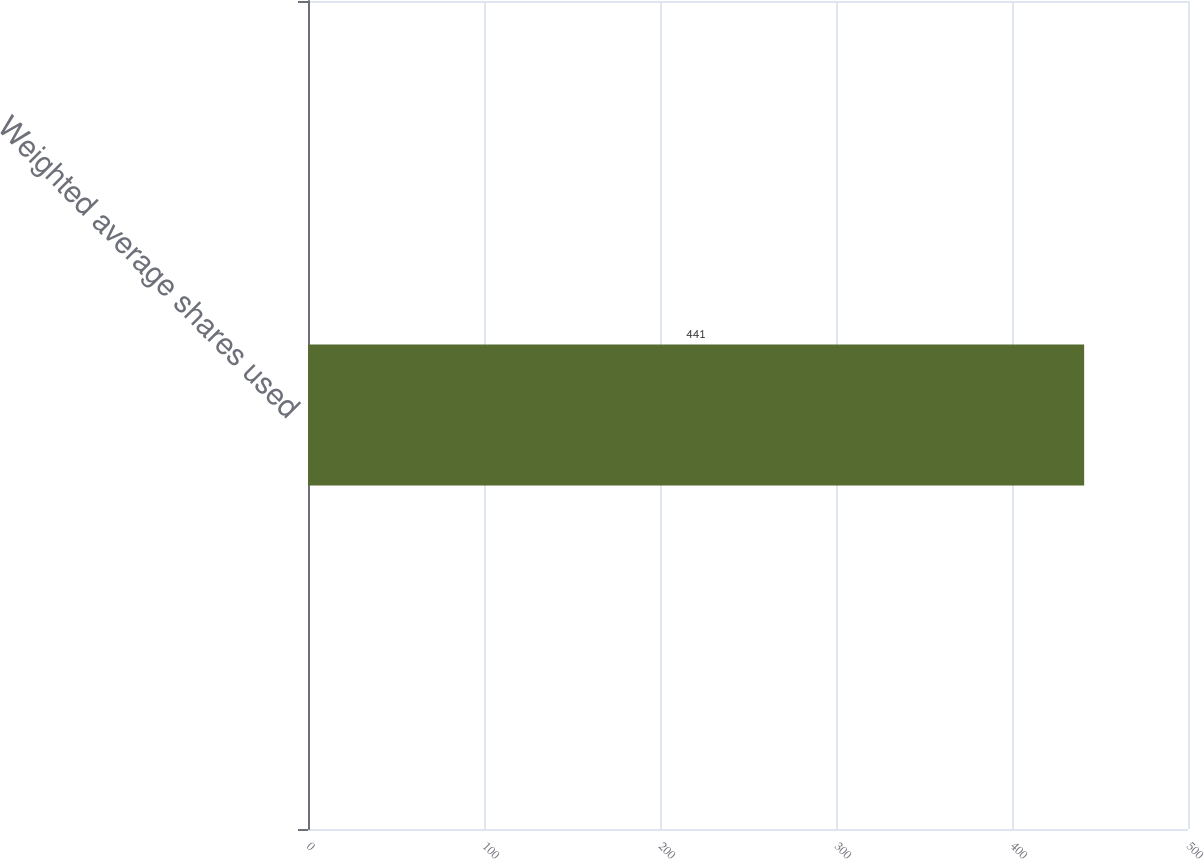<chart> <loc_0><loc_0><loc_500><loc_500><bar_chart><fcel>Weighted average shares used<nl><fcel>441<nl></chart> 